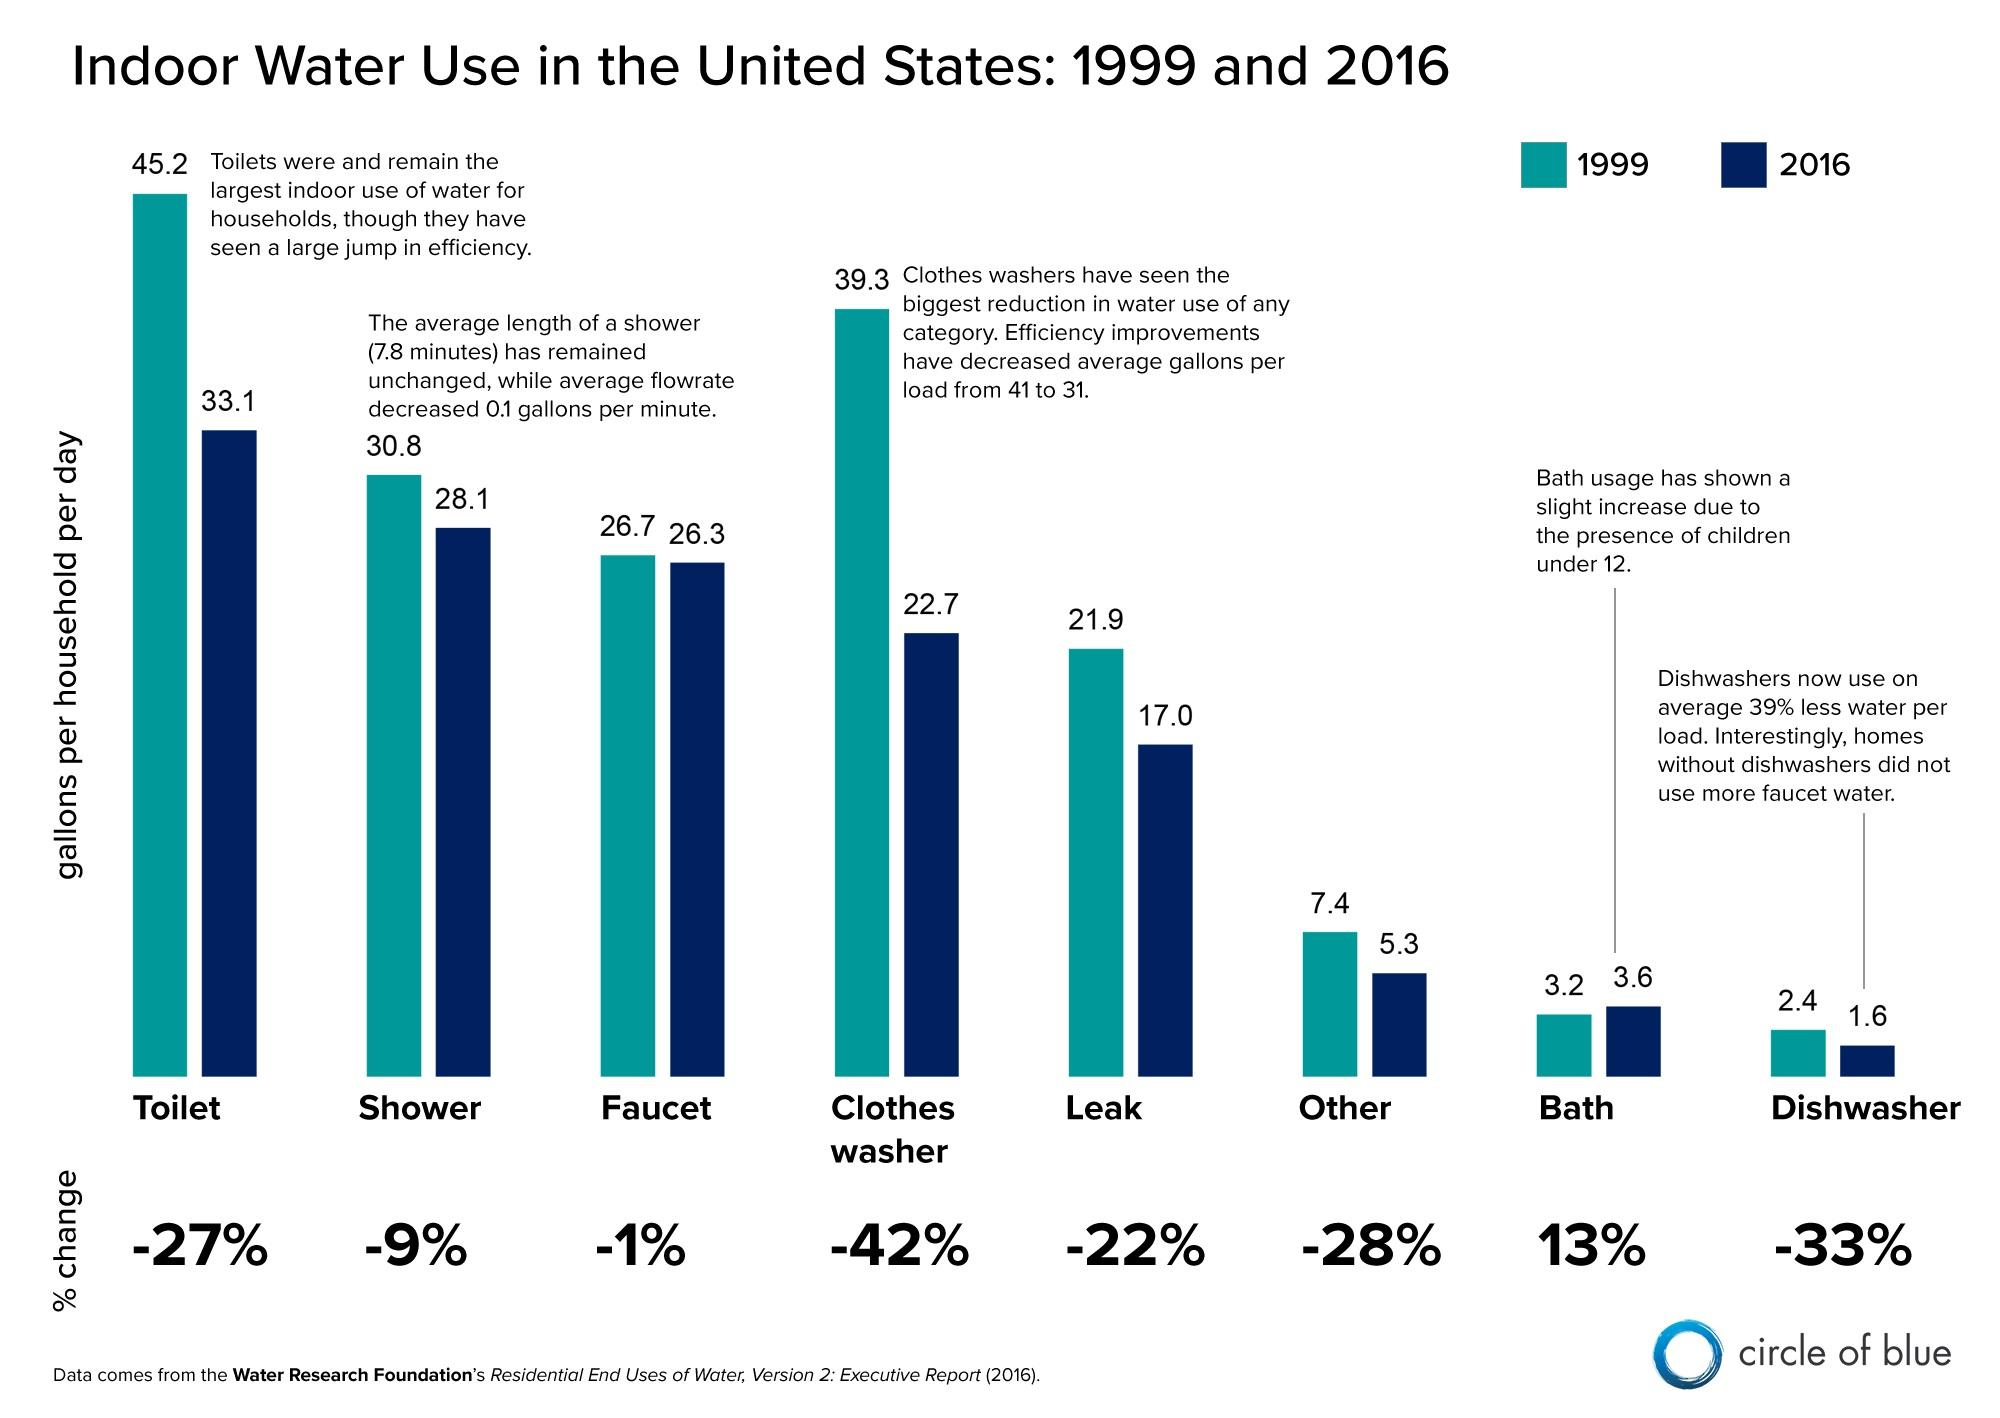Outline some significant characteristics in this image. In 2016, Bath has demonstrated an increase. In 2016, the highest water consumption was in the toilet. The percentage decrease in the use of clothes washers has been -42%. In 1999, the leak was 21.9... In 2016, the bath usage was 3.6. 